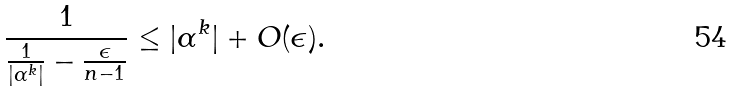Convert formula to latex. <formula><loc_0><loc_0><loc_500><loc_500>\frac { 1 } { \frac { 1 } { | \alpha ^ { k } | } - \frac { \epsilon } { n - 1 } } \leq | \alpha ^ { k } | + O ( \epsilon ) .</formula> 